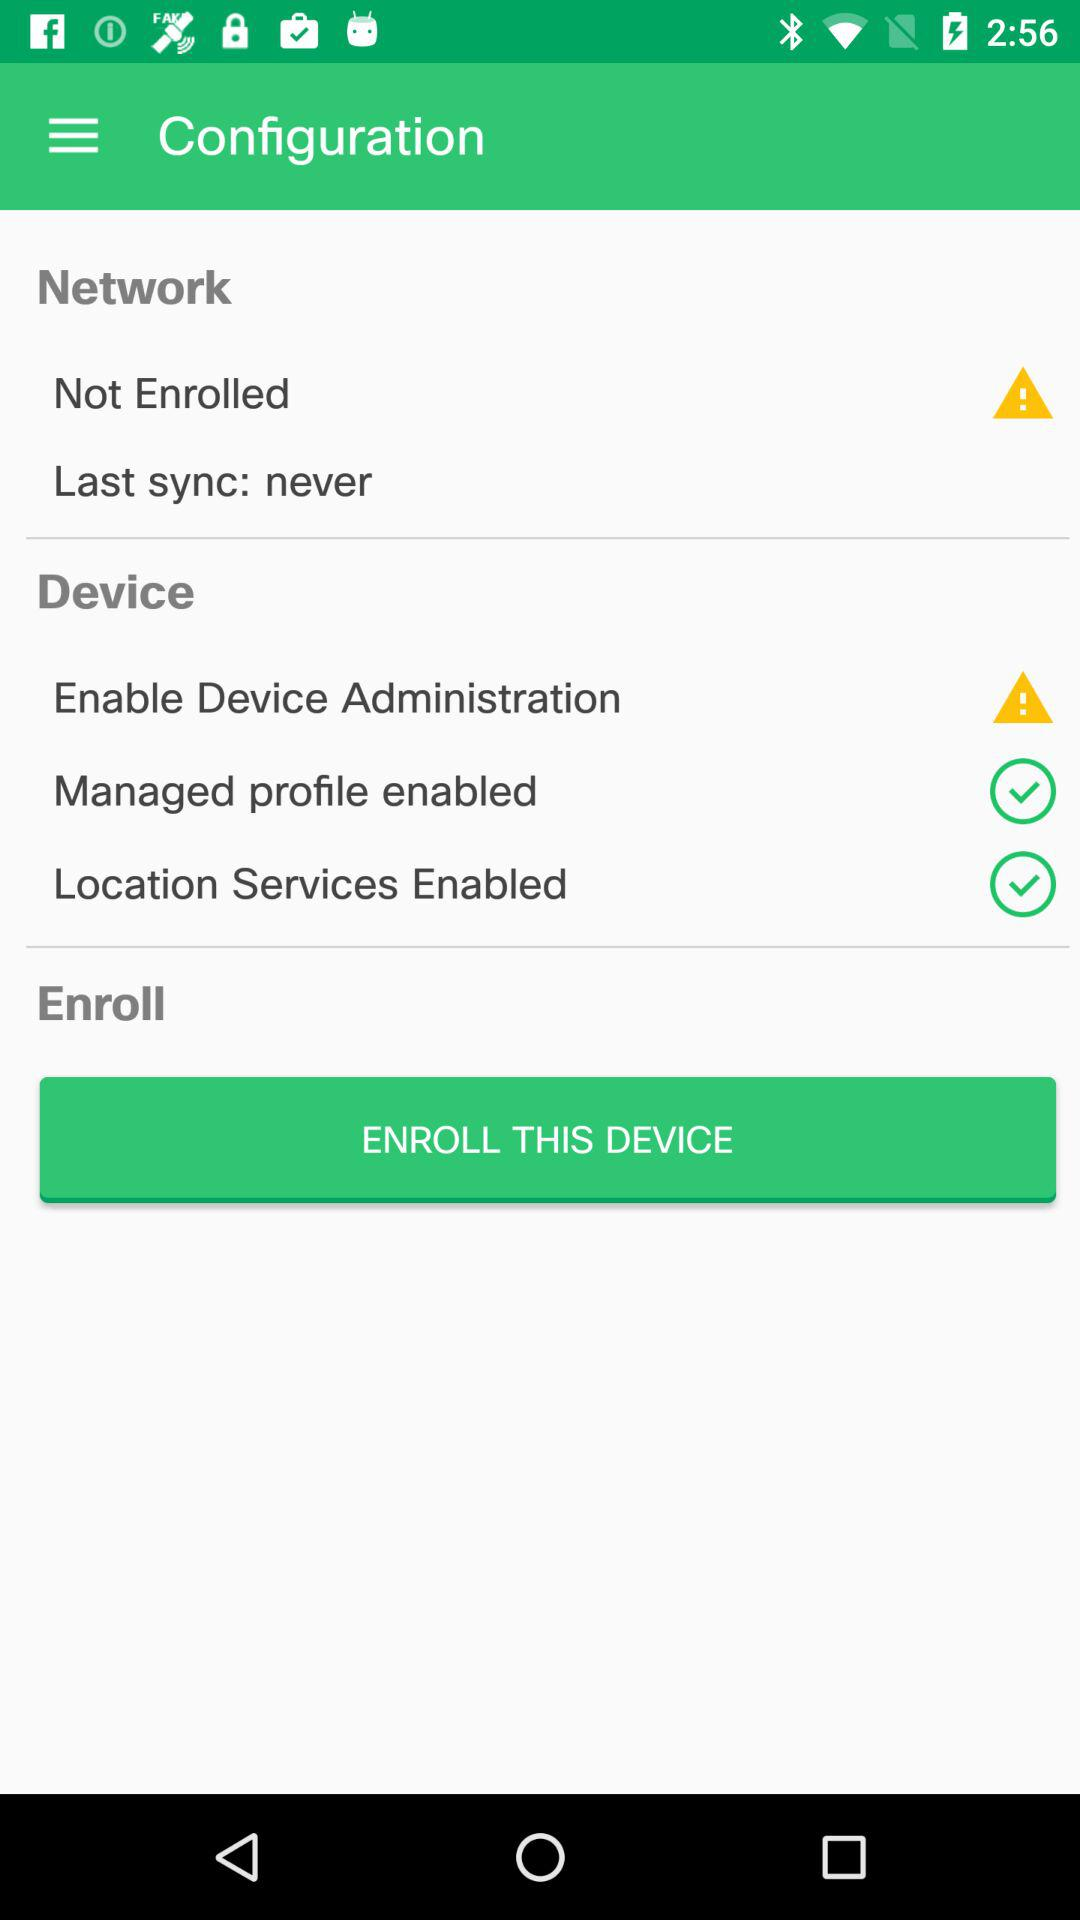What is the status of the location service? The status is "on". 